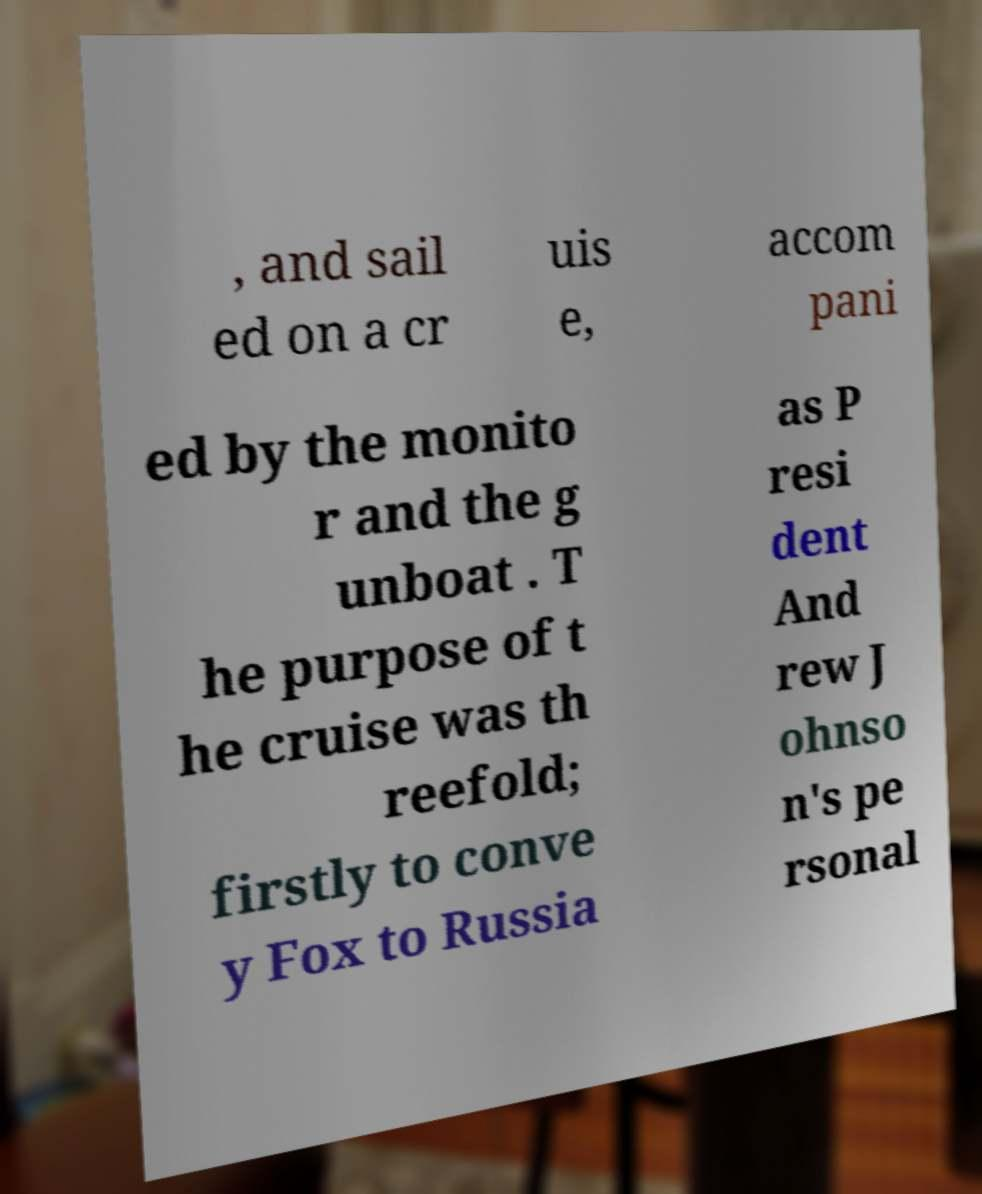Can you accurately transcribe the text from the provided image for me? , and sail ed on a cr uis e, accom pani ed by the monito r and the g unboat . T he purpose of t he cruise was th reefold; firstly to conve y Fox to Russia as P resi dent And rew J ohnso n's pe rsonal 